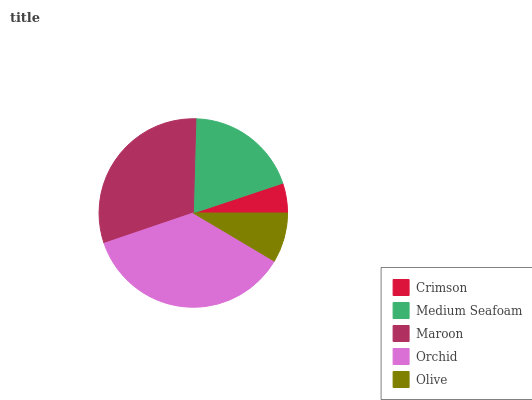Is Crimson the minimum?
Answer yes or no. Yes. Is Orchid the maximum?
Answer yes or no. Yes. Is Medium Seafoam the minimum?
Answer yes or no. No. Is Medium Seafoam the maximum?
Answer yes or no. No. Is Medium Seafoam greater than Crimson?
Answer yes or no. Yes. Is Crimson less than Medium Seafoam?
Answer yes or no. Yes. Is Crimson greater than Medium Seafoam?
Answer yes or no. No. Is Medium Seafoam less than Crimson?
Answer yes or no. No. Is Medium Seafoam the high median?
Answer yes or no. Yes. Is Medium Seafoam the low median?
Answer yes or no. Yes. Is Olive the high median?
Answer yes or no. No. Is Maroon the low median?
Answer yes or no. No. 